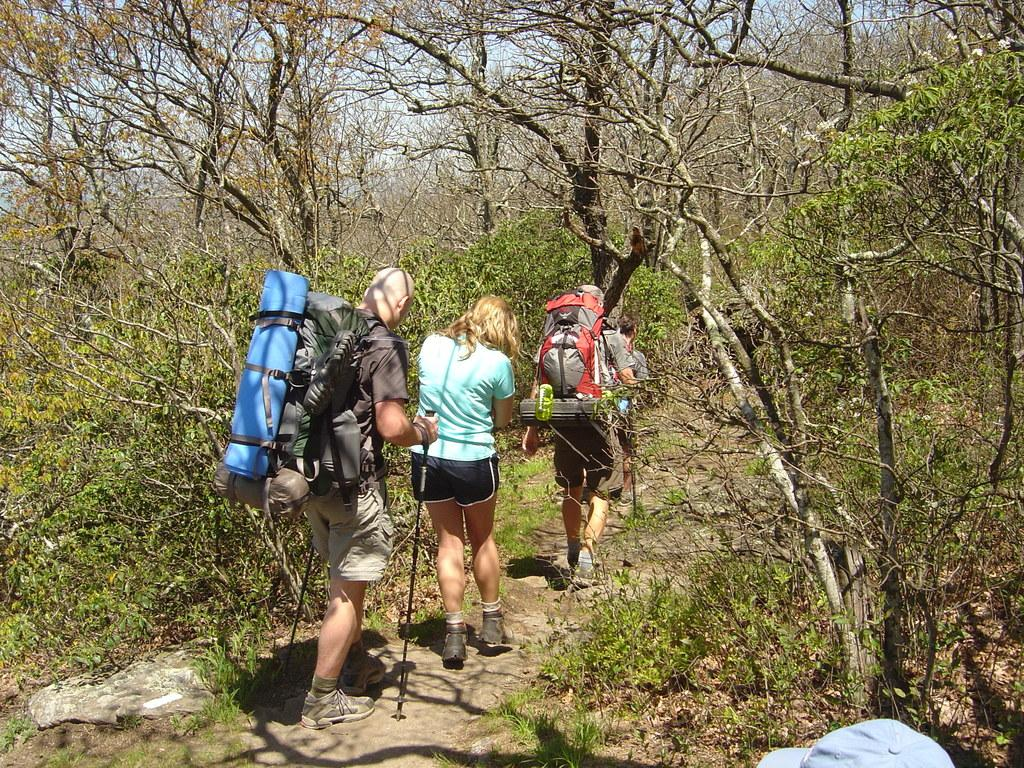Where was the image taken? The image was taken in a jungle. What are the four persons in the image doing? The four persons are walking in the center of the picture. What can be seen around the persons in the image? The area around the persons is covered with trees. Can you describe any accessories visible in the image? There is a cap visible on the right side of the image. How many tents can be seen in the image? There are no tents present in the image. What type of friction is occurring between the persons and the trees in the image? There is no information about friction between the persons and the trees in the image. Additionally, friction is a physical property and not something that can be observed visually. Can you spot a giraffe in the image? There is no giraffe present in the image. 